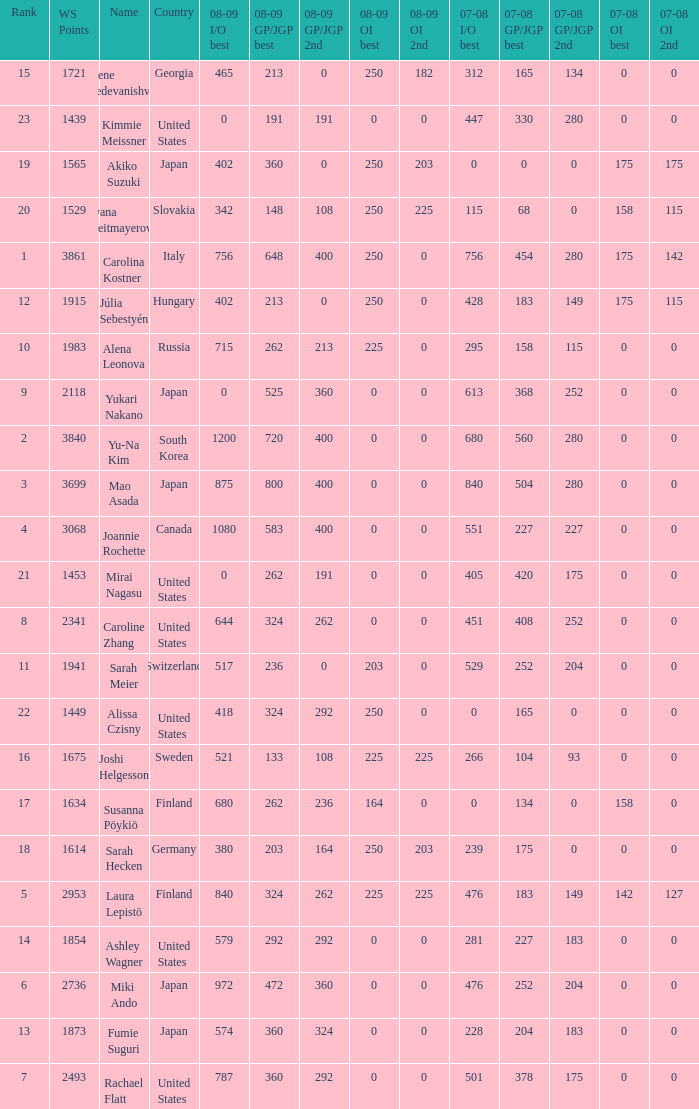08-09 gp/jgp 2nd is 213 and ws points will be what maximum 1983.0. 